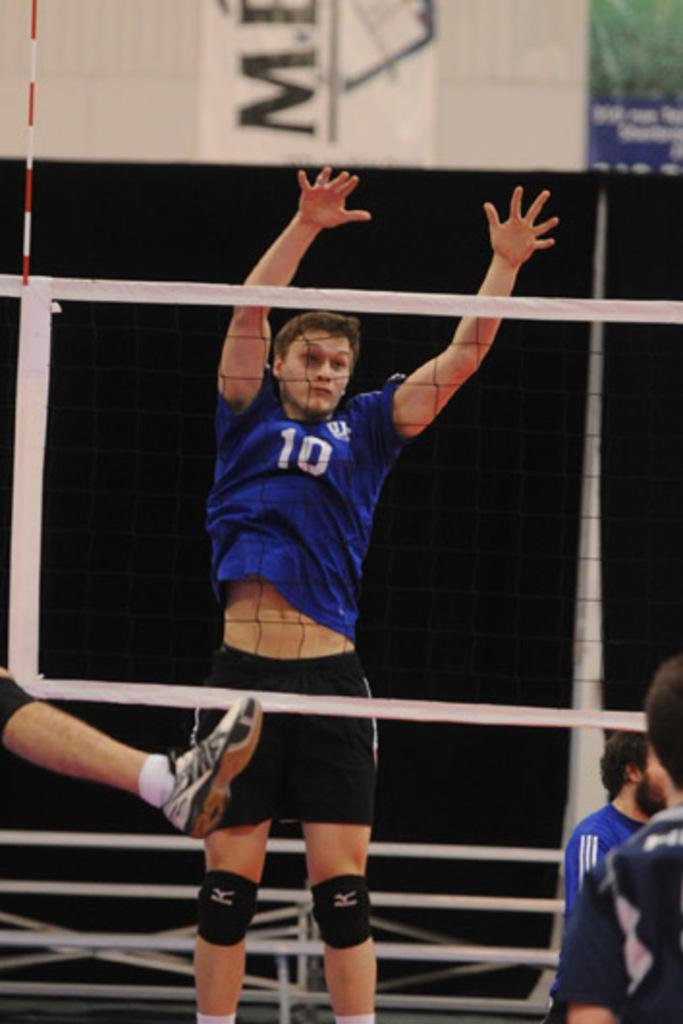Which player is that?
Keep it short and to the point. 10. What letter is on the wall?
Your answer should be very brief. M. 